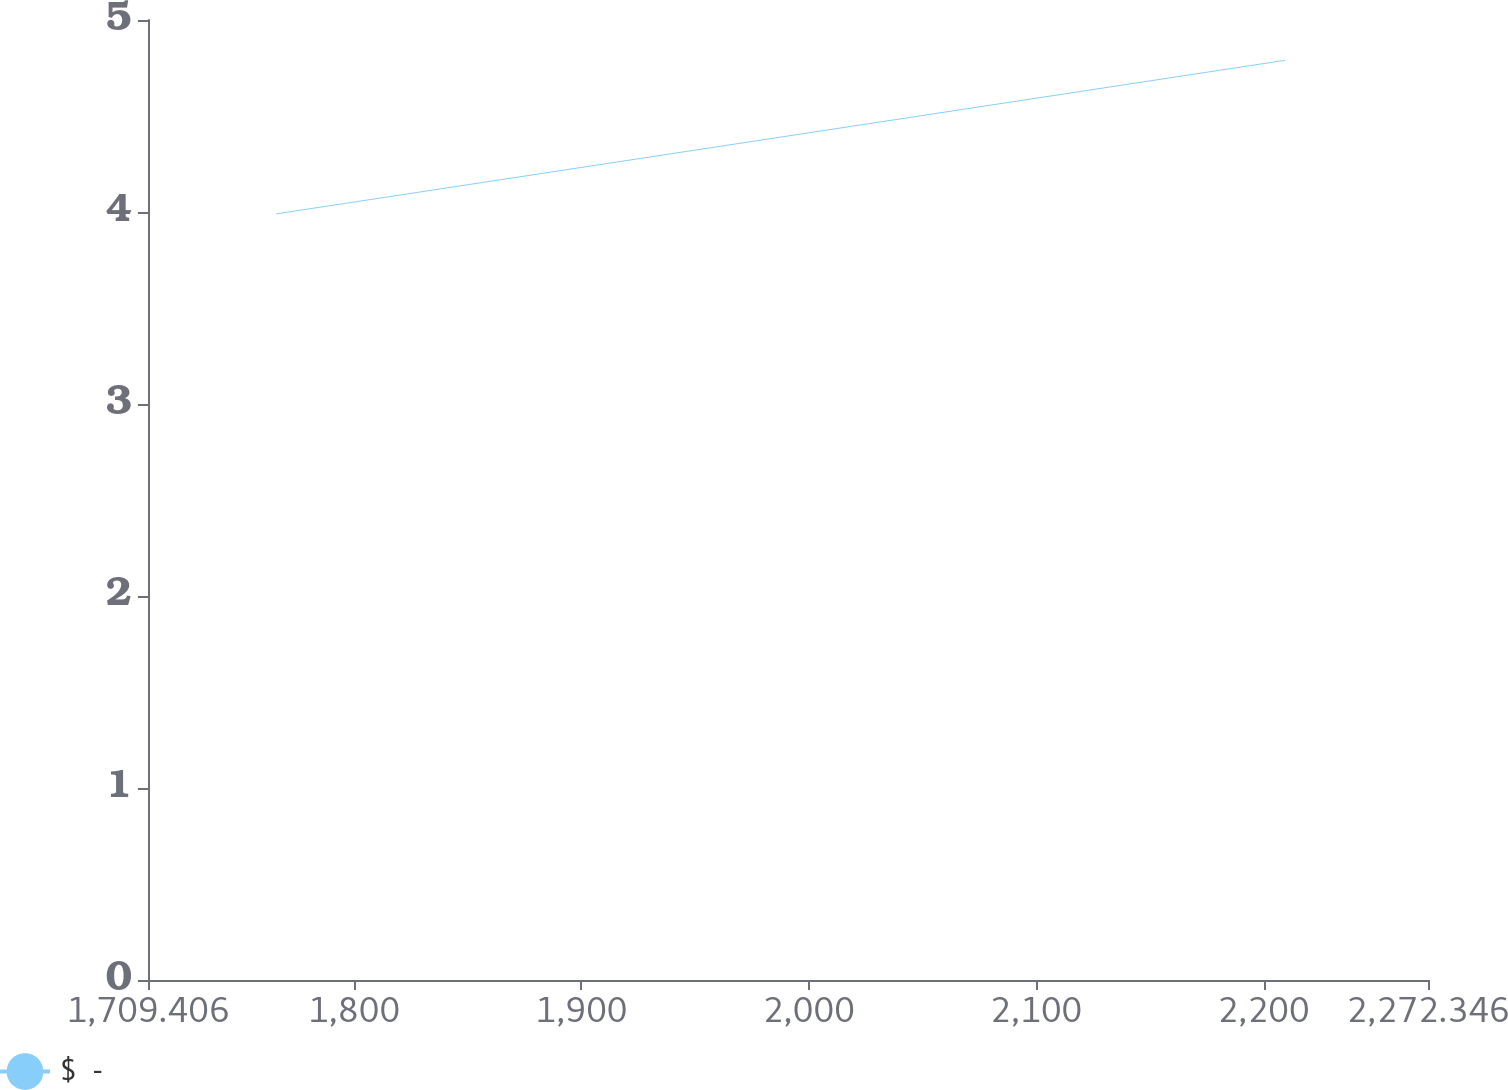<chart> <loc_0><loc_0><loc_500><loc_500><line_chart><ecel><fcel>$  -<nl><fcel>1765.7<fcel>3.99<nl><fcel>2209.48<fcel>4.79<nl><fcel>2275.43<fcel>5.54<nl><fcel>2328.64<fcel>5.36<nl></chart> 